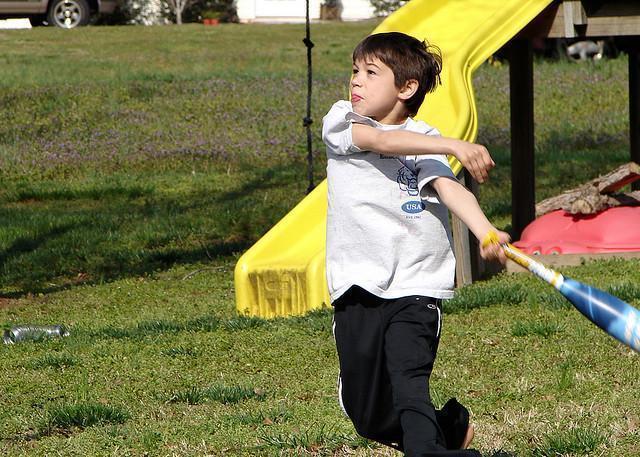What is the boy looking at?
Select the correct answer and articulate reasoning with the following format: 'Answer: answer
Rationale: rationale.'
Options: Crowd, baseball, clouds, birds. Answer: baseball.
Rationale: He looks at the baseball. 